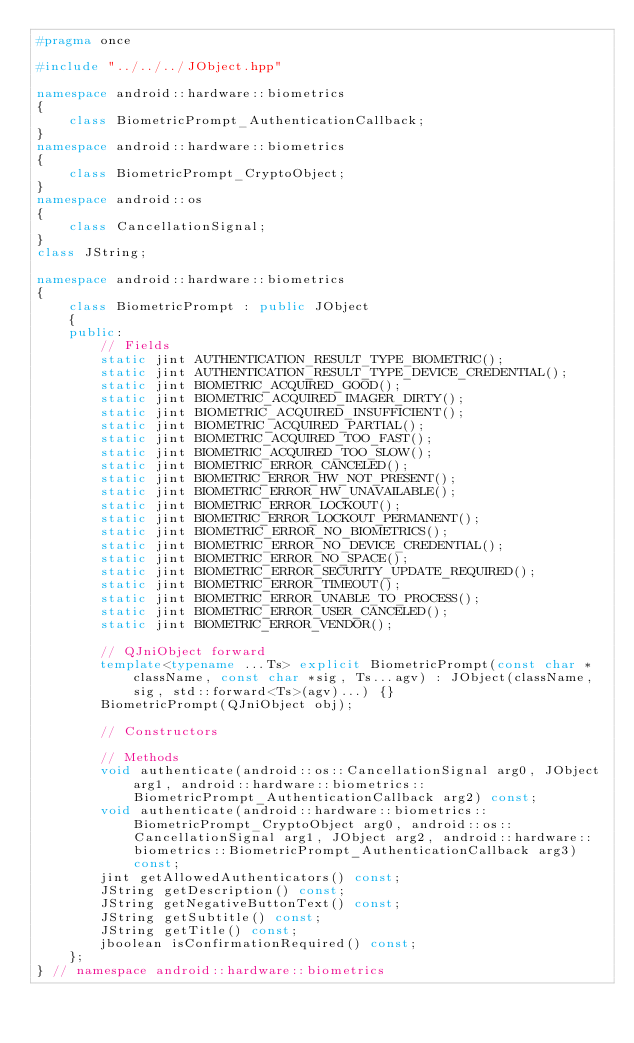<code> <loc_0><loc_0><loc_500><loc_500><_C++_>#pragma once

#include "../../../JObject.hpp"

namespace android::hardware::biometrics
{
	class BiometricPrompt_AuthenticationCallback;
}
namespace android::hardware::biometrics
{
	class BiometricPrompt_CryptoObject;
}
namespace android::os
{
	class CancellationSignal;
}
class JString;

namespace android::hardware::biometrics
{
	class BiometricPrompt : public JObject
	{
	public:
		// Fields
		static jint AUTHENTICATION_RESULT_TYPE_BIOMETRIC();
		static jint AUTHENTICATION_RESULT_TYPE_DEVICE_CREDENTIAL();
		static jint BIOMETRIC_ACQUIRED_GOOD();
		static jint BIOMETRIC_ACQUIRED_IMAGER_DIRTY();
		static jint BIOMETRIC_ACQUIRED_INSUFFICIENT();
		static jint BIOMETRIC_ACQUIRED_PARTIAL();
		static jint BIOMETRIC_ACQUIRED_TOO_FAST();
		static jint BIOMETRIC_ACQUIRED_TOO_SLOW();
		static jint BIOMETRIC_ERROR_CANCELED();
		static jint BIOMETRIC_ERROR_HW_NOT_PRESENT();
		static jint BIOMETRIC_ERROR_HW_UNAVAILABLE();
		static jint BIOMETRIC_ERROR_LOCKOUT();
		static jint BIOMETRIC_ERROR_LOCKOUT_PERMANENT();
		static jint BIOMETRIC_ERROR_NO_BIOMETRICS();
		static jint BIOMETRIC_ERROR_NO_DEVICE_CREDENTIAL();
		static jint BIOMETRIC_ERROR_NO_SPACE();
		static jint BIOMETRIC_ERROR_SECURITY_UPDATE_REQUIRED();
		static jint BIOMETRIC_ERROR_TIMEOUT();
		static jint BIOMETRIC_ERROR_UNABLE_TO_PROCESS();
		static jint BIOMETRIC_ERROR_USER_CANCELED();
		static jint BIOMETRIC_ERROR_VENDOR();
		
		// QJniObject forward
		template<typename ...Ts> explicit BiometricPrompt(const char *className, const char *sig, Ts...agv) : JObject(className, sig, std::forward<Ts>(agv)...) {}
		BiometricPrompt(QJniObject obj);
		
		// Constructors
		
		// Methods
		void authenticate(android::os::CancellationSignal arg0, JObject arg1, android::hardware::biometrics::BiometricPrompt_AuthenticationCallback arg2) const;
		void authenticate(android::hardware::biometrics::BiometricPrompt_CryptoObject arg0, android::os::CancellationSignal arg1, JObject arg2, android::hardware::biometrics::BiometricPrompt_AuthenticationCallback arg3) const;
		jint getAllowedAuthenticators() const;
		JString getDescription() const;
		JString getNegativeButtonText() const;
		JString getSubtitle() const;
		JString getTitle() const;
		jboolean isConfirmationRequired() const;
	};
} // namespace android::hardware::biometrics

</code> 